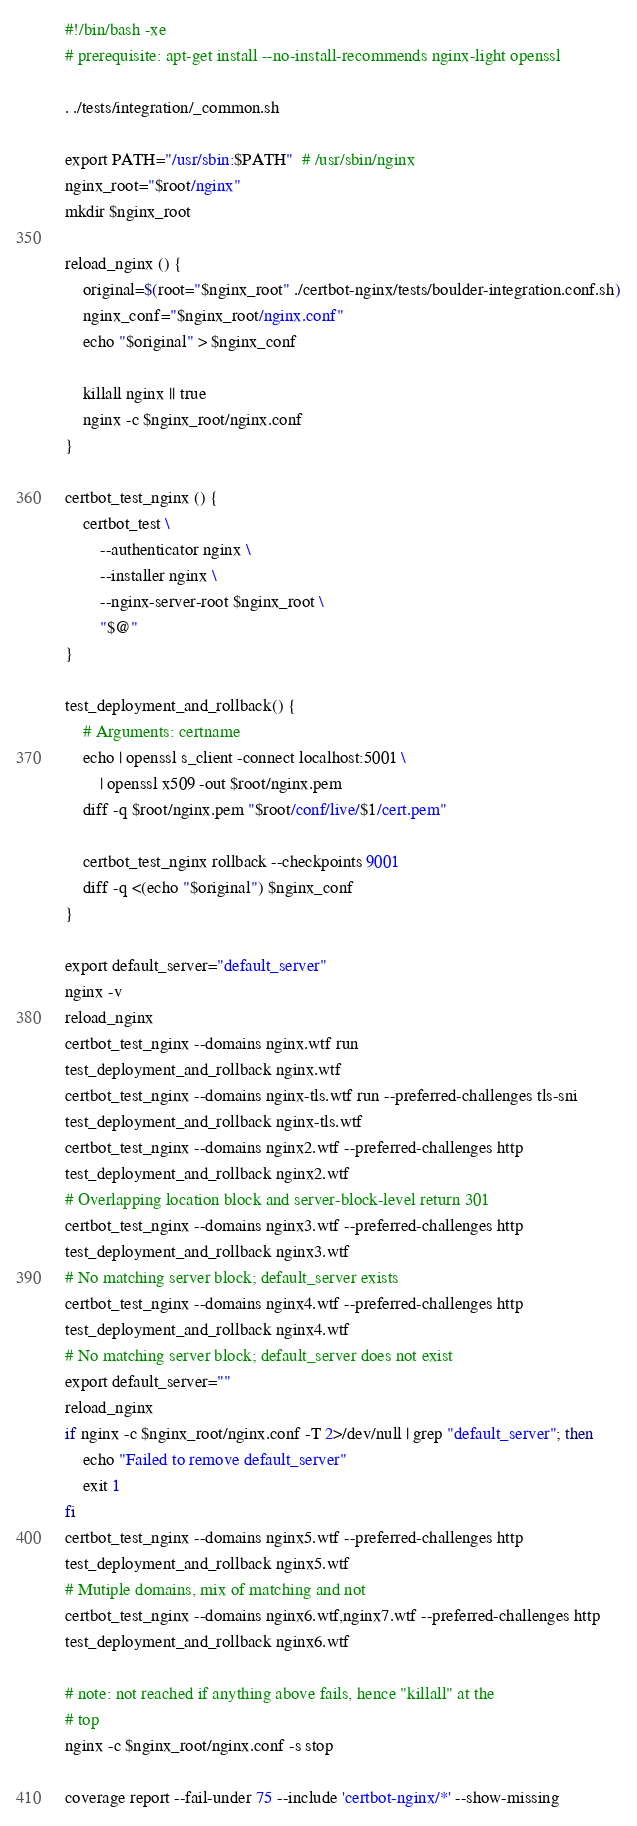<code> <loc_0><loc_0><loc_500><loc_500><_Bash_>#!/bin/bash -xe
# prerequisite: apt-get install --no-install-recommends nginx-light openssl

. ./tests/integration/_common.sh

export PATH="/usr/sbin:$PATH"  # /usr/sbin/nginx
nginx_root="$root/nginx"
mkdir $nginx_root

reload_nginx () {
    original=$(root="$nginx_root" ./certbot-nginx/tests/boulder-integration.conf.sh)
    nginx_conf="$nginx_root/nginx.conf"
    echo "$original" > $nginx_conf

    killall nginx || true
    nginx -c $nginx_root/nginx.conf
}

certbot_test_nginx () {
    certbot_test \
        --authenticator nginx \
        --installer nginx \
        --nginx-server-root $nginx_root \
        "$@"
}

test_deployment_and_rollback() {
    # Arguments: certname
    echo | openssl s_client -connect localhost:5001 \
        | openssl x509 -out $root/nginx.pem
    diff -q $root/nginx.pem "$root/conf/live/$1/cert.pem"

    certbot_test_nginx rollback --checkpoints 9001
    diff -q <(echo "$original") $nginx_conf
}

export default_server="default_server"
nginx -v
reload_nginx
certbot_test_nginx --domains nginx.wtf run
test_deployment_and_rollback nginx.wtf
certbot_test_nginx --domains nginx-tls.wtf run --preferred-challenges tls-sni
test_deployment_and_rollback nginx-tls.wtf
certbot_test_nginx --domains nginx2.wtf --preferred-challenges http
test_deployment_and_rollback nginx2.wtf
# Overlapping location block and server-block-level return 301
certbot_test_nginx --domains nginx3.wtf --preferred-challenges http
test_deployment_and_rollback nginx3.wtf
# No matching server block; default_server exists
certbot_test_nginx --domains nginx4.wtf --preferred-challenges http
test_deployment_and_rollback nginx4.wtf
# No matching server block; default_server does not exist
export default_server=""
reload_nginx
if nginx -c $nginx_root/nginx.conf -T 2>/dev/null | grep "default_server"; then
    echo "Failed to remove default_server"
    exit 1
fi
certbot_test_nginx --domains nginx5.wtf --preferred-challenges http
test_deployment_and_rollback nginx5.wtf
# Mutiple domains, mix of matching and not
certbot_test_nginx --domains nginx6.wtf,nginx7.wtf --preferred-challenges http
test_deployment_and_rollback nginx6.wtf

# note: not reached if anything above fails, hence "killall" at the
# top
nginx -c $nginx_root/nginx.conf -s stop

coverage report --fail-under 75 --include 'certbot-nginx/*' --show-missing
</code> 